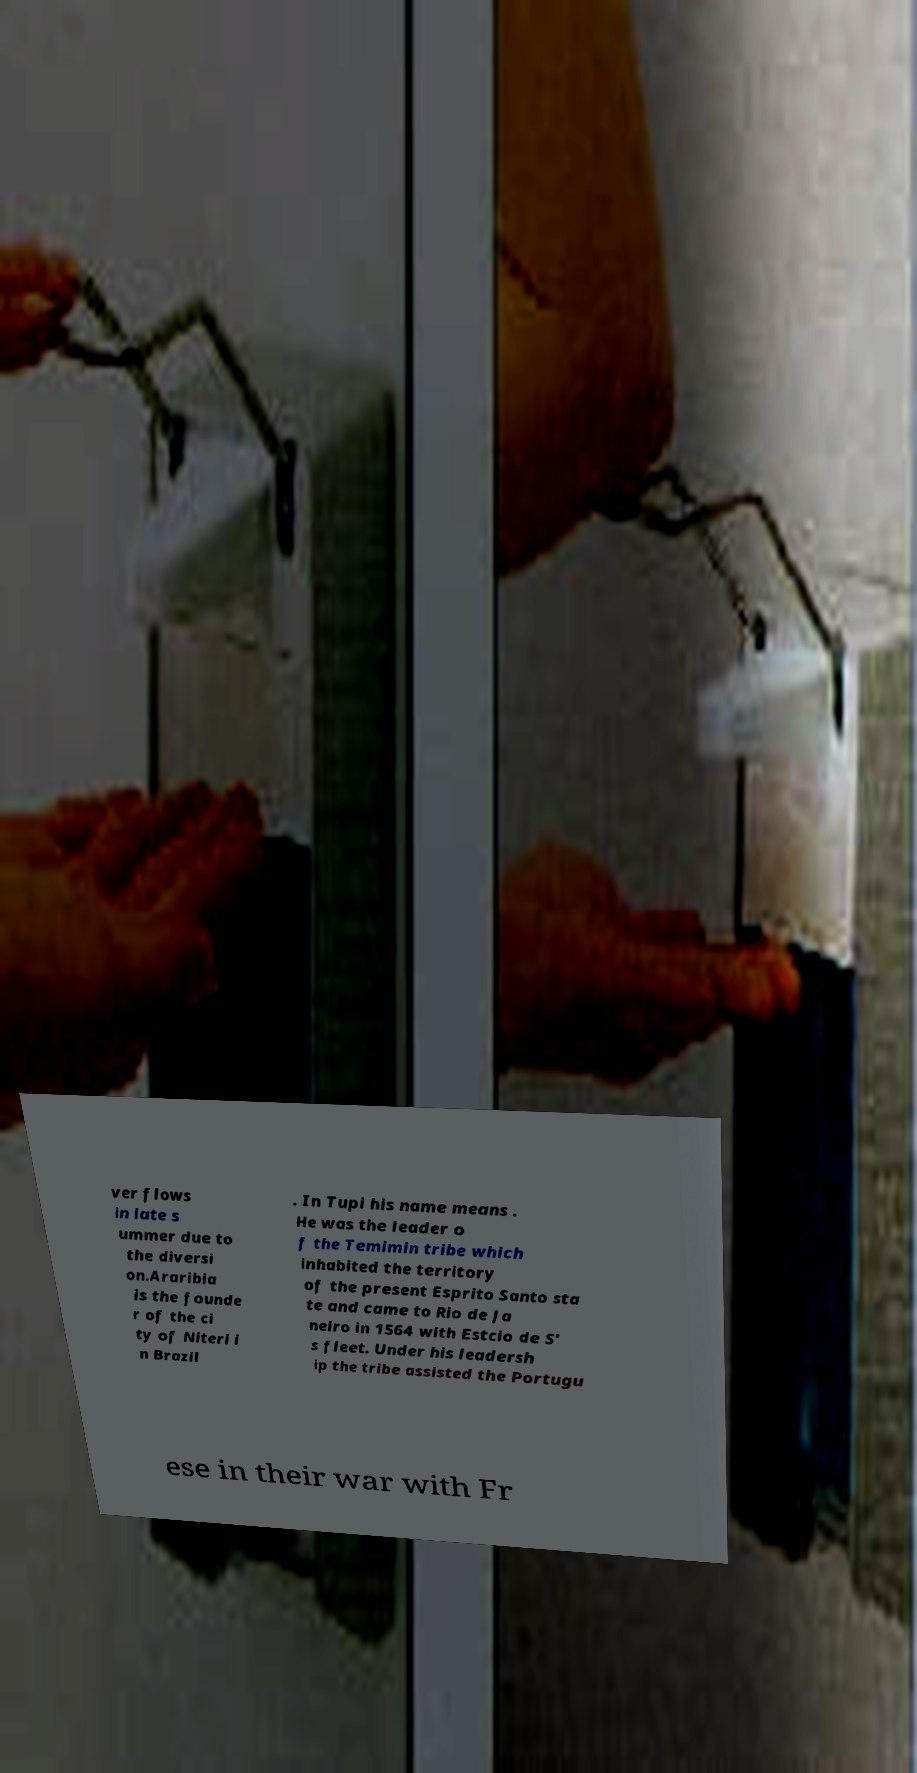I need the written content from this picture converted into text. Can you do that? ver flows in late s ummer due to the diversi on.Araribia is the founde r of the ci ty of Niteri i n Brazil . In Tupi his name means . He was the leader o f the Temimin tribe which inhabited the territory of the present Esprito Santo sta te and came to Rio de Ja neiro in 1564 with Estcio de S' s fleet. Under his leadersh ip the tribe assisted the Portugu ese in their war with Fr 